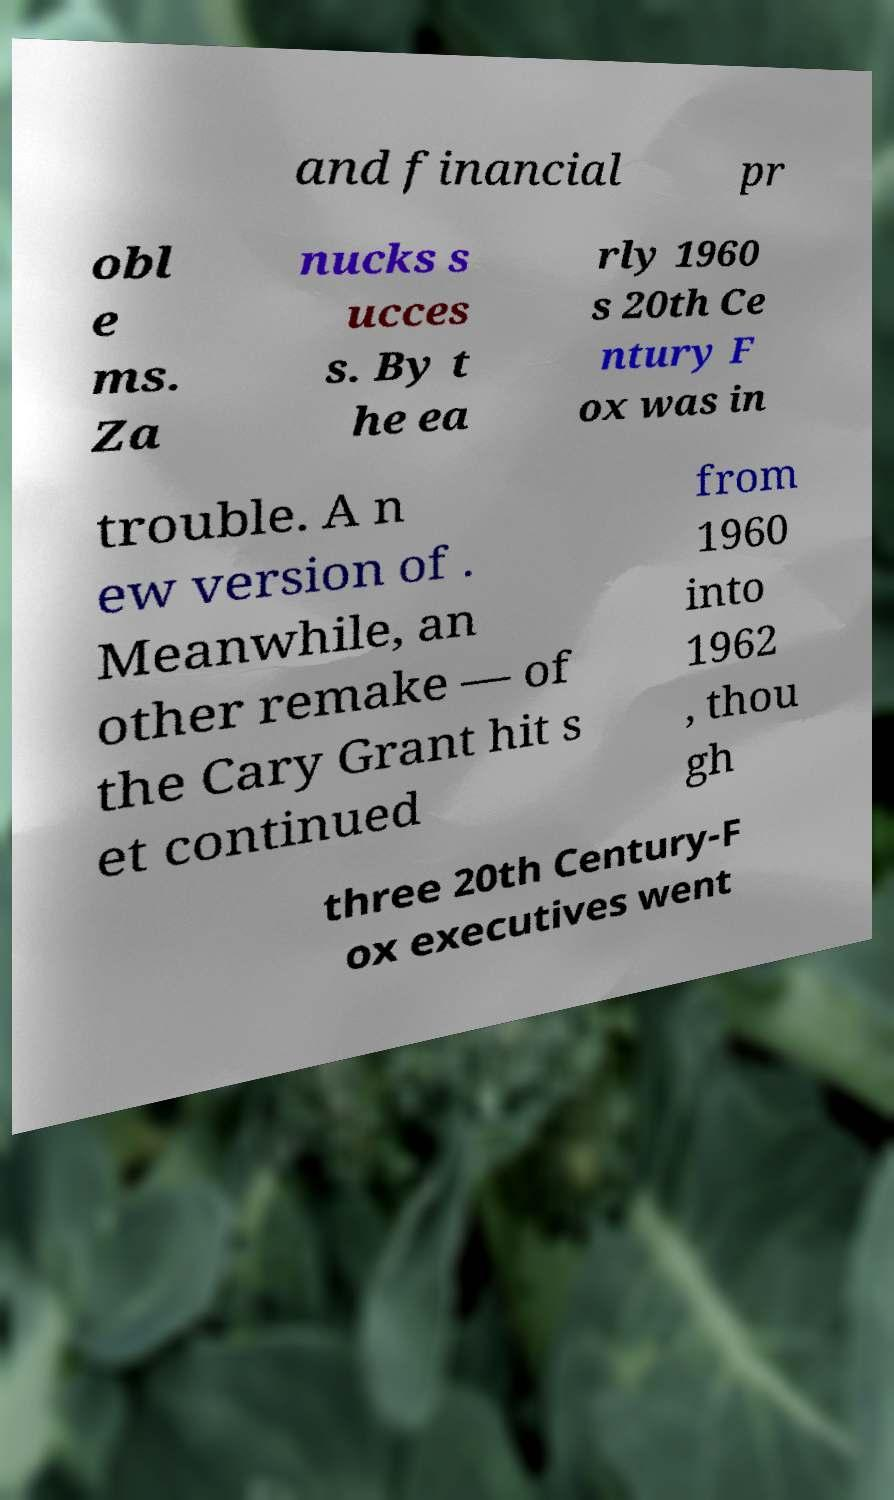I need the written content from this picture converted into text. Can you do that? and financial pr obl e ms. Za nucks s ucces s. By t he ea rly 1960 s 20th Ce ntury F ox was in trouble. A n ew version of . Meanwhile, an other remake — of the Cary Grant hit s et continued from 1960 into 1962 , thou gh three 20th Century-F ox executives went 